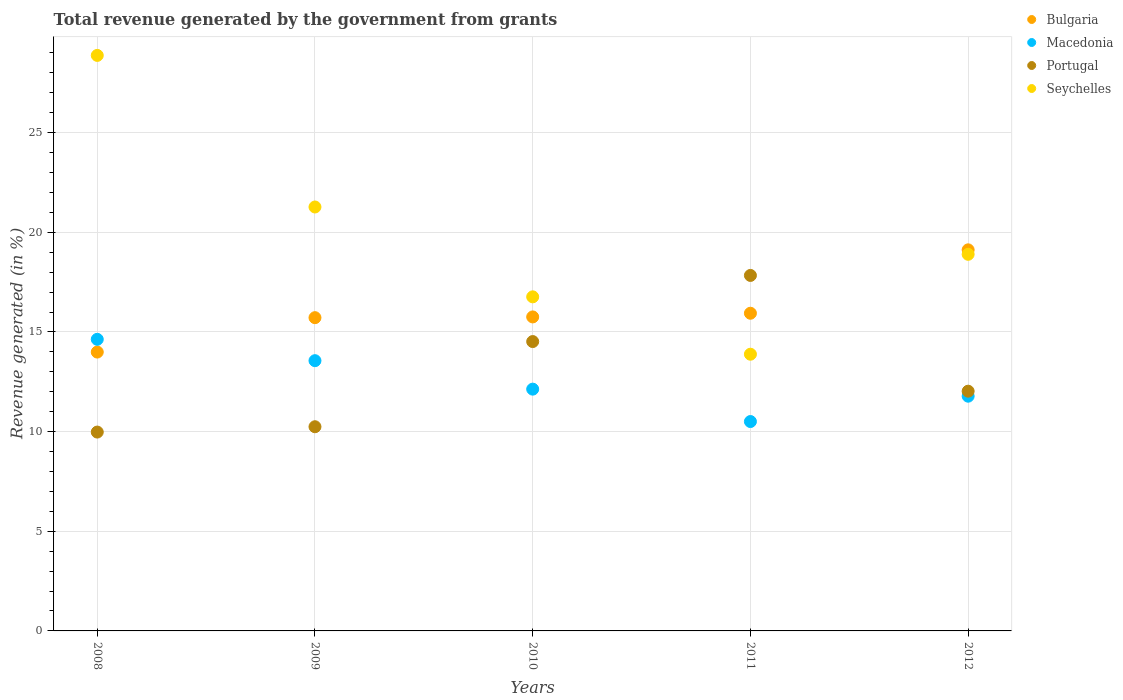What is the total revenue generated in Seychelles in 2011?
Provide a short and direct response. 13.88. Across all years, what is the maximum total revenue generated in Macedonia?
Offer a terse response. 14.63. Across all years, what is the minimum total revenue generated in Bulgaria?
Keep it short and to the point. 13.99. In which year was the total revenue generated in Macedonia maximum?
Your answer should be very brief. 2008. In which year was the total revenue generated in Bulgaria minimum?
Give a very brief answer. 2008. What is the total total revenue generated in Portugal in the graph?
Give a very brief answer. 64.61. What is the difference between the total revenue generated in Seychelles in 2010 and that in 2012?
Provide a short and direct response. -2.13. What is the difference between the total revenue generated in Bulgaria in 2008 and the total revenue generated in Macedonia in 2012?
Your response must be concise. 2.21. What is the average total revenue generated in Bulgaria per year?
Your answer should be very brief. 16.11. In the year 2012, what is the difference between the total revenue generated in Seychelles and total revenue generated in Bulgaria?
Your answer should be compact. -0.22. What is the ratio of the total revenue generated in Seychelles in 2010 to that in 2012?
Give a very brief answer. 0.89. Is the total revenue generated in Bulgaria in 2008 less than that in 2009?
Your response must be concise. Yes. Is the difference between the total revenue generated in Seychelles in 2008 and 2011 greater than the difference between the total revenue generated in Bulgaria in 2008 and 2011?
Ensure brevity in your answer.  Yes. What is the difference between the highest and the second highest total revenue generated in Macedonia?
Offer a terse response. 1.07. What is the difference between the highest and the lowest total revenue generated in Bulgaria?
Make the answer very short. 5.13. In how many years, is the total revenue generated in Portugal greater than the average total revenue generated in Portugal taken over all years?
Your answer should be compact. 2. Is the sum of the total revenue generated in Bulgaria in 2008 and 2010 greater than the maximum total revenue generated in Portugal across all years?
Offer a very short reply. Yes. How many years are there in the graph?
Ensure brevity in your answer.  5. Does the graph contain grids?
Ensure brevity in your answer.  Yes. Where does the legend appear in the graph?
Make the answer very short. Top right. What is the title of the graph?
Your answer should be very brief. Total revenue generated by the government from grants. Does "Lesotho" appear as one of the legend labels in the graph?
Give a very brief answer. No. What is the label or title of the Y-axis?
Make the answer very short. Revenue generated (in %). What is the Revenue generated (in %) of Bulgaria in 2008?
Give a very brief answer. 13.99. What is the Revenue generated (in %) of Macedonia in 2008?
Offer a terse response. 14.63. What is the Revenue generated (in %) of Portugal in 2008?
Your answer should be very brief. 9.98. What is the Revenue generated (in %) of Seychelles in 2008?
Provide a short and direct response. 28.88. What is the Revenue generated (in %) of Bulgaria in 2009?
Keep it short and to the point. 15.72. What is the Revenue generated (in %) of Macedonia in 2009?
Make the answer very short. 13.56. What is the Revenue generated (in %) of Portugal in 2009?
Provide a short and direct response. 10.25. What is the Revenue generated (in %) in Seychelles in 2009?
Make the answer very short. 21.27. What is the Revenue generated (in %) of Bulgaria in 2010?
Your answer should be compact. 15.76. What is the Revenue generated (in %) in Macedonia in 2010?
Make the answer very short. 12.13. What is the Revenue generated (in %) of Portugal in 2010?
Make the answer very short. 14.52. What is the Revenue generated (in %) of Seychelles in 2010?
Make the answer very short. 16.76. What is the Revenue generated (in %) in Bulgaria in 2011?
Your response must be concise. 15.94. What is the Revenue generated (in %) in Macedonia in 2011?
Your response must be concise. 10.51. What is the Revenue generated (in %) in Portugal in 2011?
Keep it short and to the point. 17.84. What is the Revenue generated (in %) in Seychelles in 2011?
Your answer should be compact. 13.88. What is the Revenue generated (in %) of Bulgaria in 2012?
Your answer should be very brief. 19.12. What is the Revenue generated (in %) of Macedonia in 2012?
Provide a succinct answer. 11.78. What is the Revenue generated (in %) of Portugal in 2012?
Make the answer very short. 12.03. What is the Revenue generated (in %) of Seychelles in 2012?
Give a very brief answer. 18.9. Across all years, what is the maximum Revenue generated (in %) in Bulgaria?
Make the answer very short. 19.12. Across all years, what is the maximum Revenue generated (in %) in Macedonia?
Your answer should be compact. 14.63. Across all years, what is the maximum Revenue generated (in %) in Portugal?
Your response must be concise. 17.84. Across all years, what is the maximum Revenue generated (in %) of Seychelles?
Your answer should be compact. 28.88. Across all years, what is the minimum Revenue generated (in %) in Bulgaria?
Your answer should be compact. 13.99. Across all years, what is the minimum Revenue generated (in %) in Macedonia?
Offer a terse response. 10.51. Across all years, what is the minimum Revenue generated (in %) in Portugal?
Your response must be concise. 9.98. Across all years, what is the minimum Revenue generated (in %) in Seychelles?
Make the answer very short. 13.88. What is the total Revenue generated (in %) of Bulgaria in the graph?
Keep it short and to the point. 80.53. What is the total Revenue generated (in %) of Macedonia in the graph?
Your response must be concise. 62.61. What is the total Revenue generated (in %) of Portugal in the graph?
Your answer should be compact. 64.61. What is the total Revenue generated (in %) in Seychelles in the graph?
Your answer should be compact. 99.69. What is the difference between the Revenue generated (in %) of Bulgaria in 2008 and that in 2009?
Your response must be concise. -1.73. What is the difference between the Revenue generated (in %) in Macedonia in 2008 and that in 2009?
Your answer should be compact. 1.07. What is the difference between the Revenue generated (in %) of Portugal in 2008 and that in 2009?
Your answer should be compact. -0.27. What is the difference between the Revenue generated (in %) in Seychelles in 2008 and that in 2009?
Give a very brief answer. 7.61. What is the difference between the Revenue generated (in %) of Bulgaria in 2008 and that in 2010?
Keep it short and to the point. -1.76. What is the difference between the Revenue generated (in %) in Macedonia in 2008 and that in 2010?
Your response must be concise. 2.5. What is the difference between the Revenue generated (in %) of Portugal in 2008 and that in 2010?
Ensure brevity in your answer.  -4.54. What is the difference between the Revenue generated (in %) in Seychelles in 2008 and that in 2010?
Offer a very short reply. 12.11. What is the difference between the Revenue generated (in %) in Bulgaria in 2008 and that in 2011?
Ensure brevity in your answer.  -1.95. What is the difference between the Revenue generated (in %) in Macedonia in 2008 and that in 2011?
Ensure brevity in your answer.  4.12. What is the difference between the Revenue generated (in %) in Portugal in 2008 and that in 2011?
Your answer should be compact. -7.86. What is the difference between the Revenue generated (in %) in Seychelles in 2008 and that in 2011?
Make the answer very short. 14.99. What is the difference between the Revenue generated (in %) of Bulgaria in 2008 and that in 2012?
Ensure brevity in your answer.  -5.13. What is the difference between the Revenue generated (in %) in Macedonia in 2008 and that in 2012?
Your response must be concise. 2.85. What is the difference between the Revenue generated (in %) in Portugal in 2008 and that in 2012?
Your response must be concise. -2.05. What is the difference between the Revenue generated (in %) of Seychelles in 2008 and that in 2012?
Your answer should be compact. 9.98. What is the difference between the Revenue generated (in %) in Bulgaria in 2009 and that in 2010?
Provide a short and direct response. -0.04. What is the difference between the Revenue generated (in %) in Macedonia in 2009 and that in 2010?
Make the answer very short. 1.43. What is the difference between the Revenue generated (in %) of Portugal in 2009 and that in 2010?
Offer a terse response. -4.27. What is the difference between the Revenue generated (in %) of Seychelles in 2009 and that in 2010?
Give a very brief answer. 4.51. What is the difference between the Revenue generated (in %) of Bulgaria in 2009 and that in 2011?
Provide a short and direct response. -0.22. What is the difference between the Revenue generated (in %) of Macedonia in 2009 and that in 2011?
Provide a short and direct response. 3.05. What is the difference between the Revenue generated (in %) of Portugal in 2009 and that in 2011?
Offer a terse response. -7.59. What is the difference between the Revenue generated (in %) of Seychelles in 2009 and that in 2011?
Ensure brevity in your answer.  7.39. What is the difference between the Revenue generated (in %) in Bulgaria in 2009 and that in 2012?
Your response must be concise. -3.4. What is the difference between the Revenue generated (in %) of Macedonia in 2009 and that in 2012?
Offer a terse response. 1.78. What is the difference between the Revenue generated (in %) of Portugal in 2009 and that in 2012?
Your response must be concise. -1.78. What is the difference between the Revenue generated (in %) of Seychelles in 2009 and that in 2012?
Ensure brevity in your answer.  2.37. What is the difference between the Revenue generated (in %) of Bulgaria in 2010 and that in 2011?
Your answer should be very brief. -0.18. What is the difference between the Revenue generated (in %) of Macedonia in 2010 and that in 2011?
Your response must be concise. 1.63. What is the difference between the Revenue generated (in %) in Portugal in 2010 and that in 2011?
Give a very brief answer. -3.32. What is the difference between the Revenue generated (in %) in Seychelles in 2010 and that in 2011?
Keep it short and to the point. 2.88. What is the difference between the Revenue generated (in %) in Bulgaria in 2010 and that in 2012?
Make the answer very short. -3.37. What is the difference between the Revenue generated (in %) in Macedonia in 2010 and that in 2012?
Your answer should be very brief. 0.35. What is the difference between the Revenue generated (in %) of Portugal in 2010 and that in 2012?
Keep it short and to the point. 2.49. What is the difference between the Revenue generated (in %) of Seychelles in 2010 and that in 2012?
Ensure brevity in your answer.  -2.13. What is the difference between the Revenue generated (in %) in Bulgaria in 2011 and that in 2012?
Give a very brief answer. -3.18. What is the difference between the Revenue generated (in %) in Macedonia in 2011 and that in 2012?
Offer a terse response. -1.27. What is the difference between the Revenue generated (in %) in Portugal in 2011 and that in 2012?
Give a very brief answer. 5.81. What is the difference between the Revenue generated (in %) in Seychelles in 2011 and that in 2012?
Provide a succinct answer. -5.01. What is the difference between the Revenue generated (in %) in Bulgaria in 2008 and the Revenue generated (in %) in Macedonia in 2009?
Provide a succinct answer. 0.43. What is the difference between the Revenue generated (in %) in Bulgaria in 2008 and the Revenue generated (in %) in Portugal in 2009?
Make the answer very short. 3.75. What is the difference between the Revenue generated (in %) in Bulgaria in 2008 and the Revenue generated (in %) in Seychelles in 2009?
Provide a succinct answer. -7.28. What is the difference between the Revenue generated (in %) in Macedonia in 2008 and the Revenue generated (in %) in Portugal in 2009?
Provide a short and direct response. 4.39. What is the difference between the Revenue generated (in %) of Macedonia in 2008 and the Revenue generated (in %) of Seychelles in 2009?
Give a very brief answer. -6.64. What is the difference between the Revenue generated (in %) in Portugal in 2008 and the Revenue generated (in %) in Seychelles in 2009?
Offer a terse response. -11.29. What is the difference between the Revenue generated (in %) of Bulgaria in 2008 and the Revenue generated (in %) of Macedonia in 2010?
Make the answer very short. 1.86. What is the difference between the Revenue generated (in %) in Bulgaria in 2008 and the Revenue generated (in %) in Portugal in 2010?
Give a very brief answer. -0.53. What is the difference between the Revenue generated (in %) in Bulgaria in 2008 and the Revenue generated (in %) in Seychelles in 2010?
Your response must be concise. -2.77. What is the difference between the Revenue generated (in %) in Macedonia in 2008 and the Revenue generated (in %) in Portugal in 2010?
Give a very brief answer. 0.11. What is the difference between the Revenue generated (in %) of Macedonia in 2008 and the Revenue generated (in %) of Seychelles in 2010?
Provide a short and direct response. -2.13. What is the difference between the Revenue generated (in %) of Portugal in 2008 and the Revenue generated (in %) of Seychelles in 2010?
Offer a terse response. -6.79. What is the difference between the Revenue generated (in %) in Bulgaria in 2008 and the Revenue generated (in %) in Macedonia in 2011?
Your answer should be compact. 3.49. What is the difference between the Revenue generated (in %) of Bulgaria in 2008 and the Revenue generated (in %) of Portugal in 2011?
Make the answer very short. -3.85. What is the difference between the Revenue generated (in %) in Bulgaria in 2008 and the Revenue generated (in %) in Seychelles in 2011?
Your response must be concise. 0.11. What is the difference between the Revenue generated (in %) of Macedonia in 2008 and the Revenue generated (in %) of Portugal in 2011?
Give a very brief answer. -3.21. What is the difference between the Revenue generated (in %) in Macedonia in 2008 and the Revenue generated (in %) in Seychelles in 2011?
Offer a terse response. 0.75. What is the difference between the Revenue generated (in %) of Portugal in 2008 and the Revenue generated (in %) of Seychelles in 2011?
Offer a very short reply. -3.91. What is the difference between the Revenue generated (in %) of Bulgaria in 2008 and the Revenue generated (in %) of Macedonia in 2012?
Offer a very short reply. 2.21. What is the difference between the Revenue generated (in %) in Bulgaria in 2008 and the Revenue generated (in %) in Portugal in 2012?
Offer a very short reply. 1.96. What is the difference between the Revenue generated (in %) in Bulgaria in 2008 and the Revenue generated (in %) in Seychelles in 2012?
Ensure brevity in your answer.  -4.91. What is the difference between the Revenue generated (in %) of Macedonia in 2008 and the Revenue generated (in %) of Portugal in 2012?
Provide a succinct answer. 2.6. What is the difference between the Revenue generated (in %) of Macedonia in 2008 and the Revenue generated (in %) of Seychelles in 2012?
Provide a short and direct response. -4.27. What is the difference between the Revenue generated (in %) in Portugal in 2008 and the Revenue generated (in %) in Seychelles in 2012?
Give a very brief answer. -8.92. What is the difference between the Revenue generated (in %) of Bulgaria in 2009 and the Revenue generated (in %) of Macedonia in 2010?
Provide a succinct answer. 3.59. What is the difference between the Revenue generated (in %) in Bulgaria in 2009 and the Revenue generated (in %) in Portugal in 2010?
Give a very brief answer. 1.2. What is the difference between the Revenue generated (in %) in Bulgaria in 2009 and the Revenue generated (in %) in Seychelles in 2010?
Your answer should be very brief. -1.04. What is the difference between the Revenue generated (in %) in Macedonia in 2009 and the Revenue generated (in %) in Portugal in 2010?
Your answer should be compact. -0.96. What is the difference between the Revenue generated (in %) in Macedonia in 2009 and the Revenue generated (in %) in Seychelles in 2010?
Your response must be concise. -3.2. What is the difference between the Revenue generated (in %) in Portugal in 2009 and the Revenue generated (in %) in Seychelles in 2010?
Provide a short and direct response. -6.52. What is the difference between the Revenue generated (in %) of Bulgaria in 2009 and the Revenue generated (in %) of Macedonia in 2011?
Offer a terse response. 5.21. What is the difference between the Revenue generated (in %) in Bulgaria in 2009 and the Revenue generated (in %) in Portugal in 2011?
Keep it short and to the point. -2.12. What is the difference between the Revenue generated (in %) of Bulgaria in 2009 and the Revenue generated (in %) of Seychelles in 2011?
Your answer should be very brief. 1.83. What is the difference between the Revenue generated (in %) in Macedonia in 2009 and the Revenue generated (in %) in Portugal in 2011?
Provide a short and direct response. -4.28. What is the difference between the Revenue generated (in %) of Macedonia in 2009 and the Revenue generated (in %) of Seychelles in 2011?
Offer a very short reply. -0.32. What is the difference between the Revenue generated (in %) of Portugal in 2009 and the Revenue generated (in %) of Seychelles in 2011?
Your answer should be very brief. -3.64. What is the difference between the Revenue generated (in %) in Bulgaria in 2009 and the Revenue generated (in %) in Macedonia in 2012?
Keep it short and to the point. 3.94. What is the difference between the Revenue generated (in %) in Bulgaria in 2009 and the Revenue generated (in %) in Portugal in 2012?
Offer a terse response. 3.69. What is the difference between the Revenue generated (in %) in Bulgaria in 2009 and the Revenue generated (in %) in Seychelles in 2012?
Offer a terse response. -3.18. What is the difference between the Revenue generated (in %) in Macedonia in 2009 and the Revenue generated (in %) in Portugal in 2012?
Give a very brief answer. 1.53. What is the difference between the Revenue generated (in %) of Macedonia in 2009 and the Revenue generated (in %) of Seychelles in 2012?
Ensure brevity in your answer.  -5.34. What is the difference between the Revenue generated (in %) of Portugal in 2009 and the Revenue generated (in %) of Seychelles in 2012?
Your answer should be very brief. -8.65. What is the difference between the Revenue generated (in %) of Bulgaria in 2010 and the Revenue generated (in %) of Macedonia in 2011?
Offer a terse response. 5.25. What is the difference between the Revenue generated (in %) in Bulgaria in 2010 and the Revenue generated (in %) in Portugal in 2011?
Offer a very short reply. -2.08. What is the difference between the Revenue generated (in %) in Bulgaria in 2010 and the Revenue generated (in %) in Seychelles in 2011?
Keep it short and to the point. 1.87. What is the difference between the Revenue generated (in %) of Macedonia in 2010 and the Revenue generated (in %) of Portugal in 2011?
Your response must be concise. -5.71. What is the difference between the Revenue generated (in %) of Macedonia in 2010 and the Revenue generated (in %) of Seychelles in 2011?
Ensure brevity in your answer.  -1.75. What is the difference between the Revenue generated (in %) of Portugal in 2010 and the Revenue generated (in %) of Seychelles in 2011?
Your answer should be very brief. 0.64. What is the difference between the Revenue generated (in %) in Bulgaria in 2010 and the Revenue generated (in %) in Macedonia in 2012?
Offer a very short reply. 3.98. What is the difference between the Revenue generated (in %) in Bulgaria in 2010 and the Revenue generated (in %) in Portugal in 2012?
Ensure brevity in your answer.  3.73. What is the difference between the Revenue generated (in %) of Bulgaria in 2010 and the Revenue generated (in %) of Seychelles in 2012?
Provide a succinct answer. -3.14. What is the difference between the Revenue generated (in %) of Macedonia in 2010 and the Revenue generated (in %) of Portugal in 2012?
Your answer should be very brief. 0.1. What is the difference between the Revenue generated (in %) of Macedonia in 2010 and the Revenue generated (in %) of Seychelles in 2012?
Offer a very short reply. -6.77. What is the difference between the Revenue generated (in %) in Portugal in 2010 and the Revenue generated (in %) in Seychelles in 2012?
Your answer should be very brief. -4.38. What is the difference between the Revenue generated (in %) in Bulgaria in 2011 and the Revenue generated (in %) in Macedonia in 2012?
Provide a succinct answer. 4.16. What is the difference between the Revenue generated (in %) of Bulgaria in 2011 and the Revenue generated (in %) of Portugal in 2012?
Give a very brief answer. 3.91. What is the difference between the Revenue generated (in %) in Bulgaria in 2011 and the Revenue generated (in %) in Seychelles in 2012?
Your answer should be compact. -2.96. What is the difference between the Revenue generated (in %) in Macedonia in 2011 and the Revenue generated (in %) in Portugal in 2012?
Ensure brevity in your answer.  -1.52. What is the difference between the Revenue generated (in %) in Macedonia in 2011 and the Revenue generated (in %) in Seychelles in 2012?
Keep it short and to the point. -8.39. What is the difference between the Revenue generated (in %) in Portugal in 2011 and the Revenue generated (in %) in Seychelles in 2012?
Offer a very short reply. -1.06. What is the average Revenue generated (in %) in Bulgaria per year?
Keep it short and to the point. 16.11. What is the average Revenue generated (in %) in Macedonia per year?
Offer a very short reply. 12.52. What is the average Revenue generated (in %) of Portugal per year?
Make the answer very short. 12.92. What is the average Revenue generated (in %) of Seychelles per year?
Provide a succinct answer. 19.94. In the year 2008, what is the difference between the Revenue generated (in %) in Bulgaria and Revenue generated (in %) in Macedonia?
Give a very brief answer. -0.64. In the year 2008, what is the difference between the Revenue generated (in %) of Bulgaria and Revenue generated (in %) of Portugal?
Provide a succinct answer. 4.01. In the year 2008, what is the difference between the Revenue generated (in %) in Bulgaria and Revenue generated (in %) in Seychelles?
Your answer should be very brief. -14.89. In the year 2008, what is the difference between the Revenue generated (in %) of Macedonia and Revenue generated (in %) of Portugal?
Your answer should be compact. 4.65. In the year 2008, what is the difference between the Revenue generated (in %) of Macedonia and Revenue generated (in %) of Seychelles?
Ensure brevity in your answer.  -14.25. In the year 2008, what is the difference between the Revenue generated (in %) in Portugal and Revenue generated (in %) in Seychelles?
Ensure brevity in your answer.  -18.9. In the year 2009, what is the difference between the Revenue generated (in %) of Bulgaria and Revenue generated (in %) of Macedonia?
Make the answer very short. 2.16. In the year 2009, what is the difference between the Revenue generated (in %) in Bulgaria and Revenue generated (in %) in Portugal?
Provide a succinct answer. 5.47. In the year 2009, what is the difference between the Revenue generated (in %) of Bulgaria and Revenue generated (in %) of Seychelles?
Give a very brief answer. -5.55. In the year 2009, what is the difference between the Revenue generated (in %) of Macedonia and Revenue generated (in %) of Portugal?
Provide a succinct answer. 3.31. In the year 2009, what is the difference between the Revenue generated (in %) in Macedonia and Revenue generated (in %) in Seychelles?
Offer a very short reply. -7.71. In the year 2009, what is the difference between the Revenue generated (in %) of Portugal and Revenue generated (in %) of Seychelles?
Provide a succinct answer. -11.03. In the year 2010, what is the difference between the Revenue generated (in %) of Bulgaria and Revenue generated (in %) of Macedonia?
Offer a terse response. 3.62. In the year 2010, what is the difference between the Revenue generated (in %) of Bulgaria and Revenue generated (in %) of Portugal?
Provide a succinct answer. 1.24. In the year 2010, what is the difference between the Revenue generated (in %) of Bulgaria and Revenue generated (in %) of Seychelles?
Your response must be concise. -1.01. In the year 2010, what is the difference between the Revenue generated (in %) of Macedonia and Revenue generated (in %) of Portugal?
Your answer should be very brief. -2.39. In the year 2010, what is the difference between the Revenue generated (in %) in Macedonia and Revenue generated (in %) in Seychelles?
Ensure brevity in your answer.  -4.63. In the year 2010, what is the difference between the Revenue generated (in %) of Portugal and Revenue generated (in %) of Seychelles?
Provide a succinct answer. -2.24. In the year 2011, what is the difference between the Revenue generated (in %) of Bulgaria and Revenue generated (in %) of Macedonia?
Provide a short and direct response. 5.43. In the year 2011, what is the difference between the Revenue generated (in %) of Bulgaria and Revenue generated (in %) of Portugal?
Your response must be concise. -1.9. In the year 2011, what is the difference between the Revenue generated (in %) of Bulgaria and Revenue generated (in %) of Seychelles?
Make the answer very short. 2.06. In the year 2011, what is the difference between the Revenue generated (in %) of Macedonia and Revenue generated (in %) of Portugal?
Your answer should be compact. -7.33. In the year 2011, what is the difference between the Revenue generated (in %) of Macedonia and Revenue generated (in %) of Seychelles?
Make the answer very short. -3.38. In the year 2011, what is the difference between the Revenue generated (in %) of Portugal and Revenue generated (in %) of Seychelles?
Offer a very short reply. 3.95. In the year 2012, what is the difference between the Revenue generated (in %) of Bulgaria and Revenue generated (in %) of Macedonia?
Your answer should be very brief. 7.34. In the year 2012, what is the difference between the Revenue generated (in %) of Bulgaria and Revenue generated (in %) of Portugal?
Make the answer very short. 7.09. In the year 2012, what is the difference between the Revenue generated (in %) of Bulgaria and Revenue generated (in %) of Seychelles?
Your answer should be compact. 0.22. In the year 2012, what is the difference between the Revenue generated (in %) in Macedonia and Revenue generated (in %) in Portugal?
Provide a succinct answer. -0.25. In the year 2012, what is the difference between the Revenue generated (in %) of Macedonia and Revenue generated (in %) of Seychelles?
Offer a very short reply. -7.12. In the year 2012, what is the difference between the Revenue generated (in %) in Portugal and Revenue generated (in %) in Seychelles?
Provide a short and direct response. -6.87. What is the ratio of the Revenue generated (in %) of Bulgaria in 2008 to that in 2009?
Offer a terse response. 0.89. What is the ratio of the Revenue generated (in %) of Macedonia in 2008 to that in 2009?
Ensure brevity in your answer.  1.08. What is the ratio of the Revenue generated (in %) in Portugal in 2008 to that in 2009?
Ensure brevity in your answer.  0.97. What is the ratio of the Revenue generated (in %) in Seychelles in 2008 to that in 2009?
Provide a succinct answer. 1.36. What is the ratio of the Revenue generated (in %) in Bulgaria in 2008 to that in 2010?
Keep it short and to the point. 0.89. What is the ratio of the Revenue generated (in %) in Macedonia in 2008 to that in 2010?
Offer a terse response. 1.21. What is the ratio of the Revenue generated (in %) in Portugal in 2008 to that in 2010?
Provide a short and direct response. 0.69. What is the ratio of the Revenue generated (in %) of Seychelles in 2008 to that in 2010?
Keep it short and to the point. 1.72. What is the ratio of the Revenue generated (in %) of Bulgaria in 2008 to that in 2011?
Make the answer very short. 0.88. What is the ratio of the Revenue generated (in %) in Macedonia in 2008 to that in 2011?
Your answer should be very brief. 1.39. What is the ratio of the Revenue generated (in %) of Portugal in 2008 to that in 2011?
Keep it short and to the point. 0.56. What is the ratio of the Revenue generated (in %) of Seychelles in 2008 to that in 2011?
Your answer should be compact. 2.08. What is the ratio of the Revenue generated (in %) in Bulgaria in 2008 to that in 2012?
Provide a short and direct response. 0.73. What is the ratio of the Revenue generated (in %) of Macedonia in 2008 to that in 2012?
Your response must be concise. 1.24. What is the ratio of the Revenue generated (in %) of Portugal in 2008 to that in 2012?
Offer a terse response. 0.83. What is the ratio of the Revenue generated (in %) in Seychelles in 2008 to that in 2012?
Give a very brief answer. 1.53. What is the ratio of the Revenue generated (in %) of Bulgaria in 2009 to that in 2010?
Offer a very short reply. 1. What is the ratio of the Revenue generated (in %) of Macedonia in 2009 to that in 2010?
Offer a terse response. 1.12. What is the ratio of the Revenue generated (in %) of Portugal in 2009 to that in 2010?
Make the answer very short. 0.71. What is the ratio of the Revenue generated (in %) in Seychelles in 2009 to that in 2010?
Give a very brief answer. 1.27. What is the ratio of the Revenue generated (in %) of Bulgaria in 2009 to that in 2011?
Offer a very short reply. 0.99. What is the ratio of the Revenue generated (in %) of Macedonia in 2009 to that in 2011?
Your response must be concise. 1.29. What is the ratio of the Revenue generated (in %) of Portugal in 2009 to that in 2011?
Keep it short and to the point. 0.57. What is the ratio of the Revenue generated (in %) in Seychelles in 2009 to that in 2011?
Give a very brief answer. 1.53. What is the ratio of the Revenue generated (in %) of Bulgaria in 2009 to that in 2012?
Your answer should be very brief. 0.82. What is the ratio of the Revenue generated (in %) of Macedonia in 2009 to that in 2012?
Provide a short and direct response. 1.15. What is the ratio of the Revenue generated (in %) in Portugal in 2009 to that in 2012?
Give a very brief answer. 0.85. What is the ratio of the Revenue generated (in %) in Seychelles in 2009 to that in 2012?
Provide a short and direct response. 1.13. What is the ratio of the Revenue generated (in %) of Bulgaria in 2010 to that in 2011?
Offer a very short reply. 0.99. What is the ratio of the Revenue generated (in %) of Macedonia in 2010 to that in 2011?
Give a very brief answer. 1.15. What is the ratio of the Revenue generated (in %) in Portugal in 2010 to that in 2011?
Make the answer very short. 0.81. What is the ratio of the Revenue generated (in %) in Seychelles in 2010 to that in 2011?
Give a very brief answer. 1.21. What is the ratio of the Revenue generated (in %) of Bulgaria in 2010 to that in 2012?
Provide a succinct answer. 0.82. What is the ratio of the Revenue generated (in %) in Macedonia in 2010 to that in 2012?
Offer a terse response. 1.03. What is the ratio of the Revenue generated (in %) in Portugal in 2010 to that in 2012?
Provide a succinct answer. 1.21. What is the ratio of the Revenue generated (in %) in Seychelles in 2010 to that in 2012?
Keep it short and to the point. 0.89. What is the ratio of the Revenue generated (in %) of Bulgaria in 2011 to that in 2012?
Keep it short and to the point. 0.83. What is the ratio of the Revenue generated (in %) in Macedonia in 2011 to that in 2012?
Give a very brief answer. 0.89. What is the ratio of the Revenue generated (in %) in Portugal in 2011 to that in 2012?
Your answer should be compact. 1.48. What is the ratio of the Revenue generated (in %) of Seychelles in 2011 to that in 2012?
Offer a very short reply. 0.73. What is the difference between the highest and the second highest Revenue generated (in %) in Bulgaria?
Give a very brief answer. 3.18. What is the difference between the highest and the second highest Revenue generated (in %) in Macedonia?
Your answer should be very brief. 1.07. What is the difference between the highest and the second highest Revenue generated (in %) of Portugal?
Your answer should be very brief. 3.32. What is the difference between the highest and the second highest Revenue generated (in %) in Seychelles?
Your answer should be very brief. 7.61. What is the difference between the highest and the lowest Revenue generated (in %) of Bulgaria?
Keep it short and to the point. 5.13. What is the difference between the highest and the lowest Revenue generated (in %) of Macedonia?
Keep it short and to the point. 4.12. What is the difference between the highest and the lowest Revenue generated (in %) in Portugal?
Your answer should be compact. 7.86. What is the difference between the highest and the lowest Revenue generated (in %) in Seychelles?
Your answer should be compact. 14.99. 